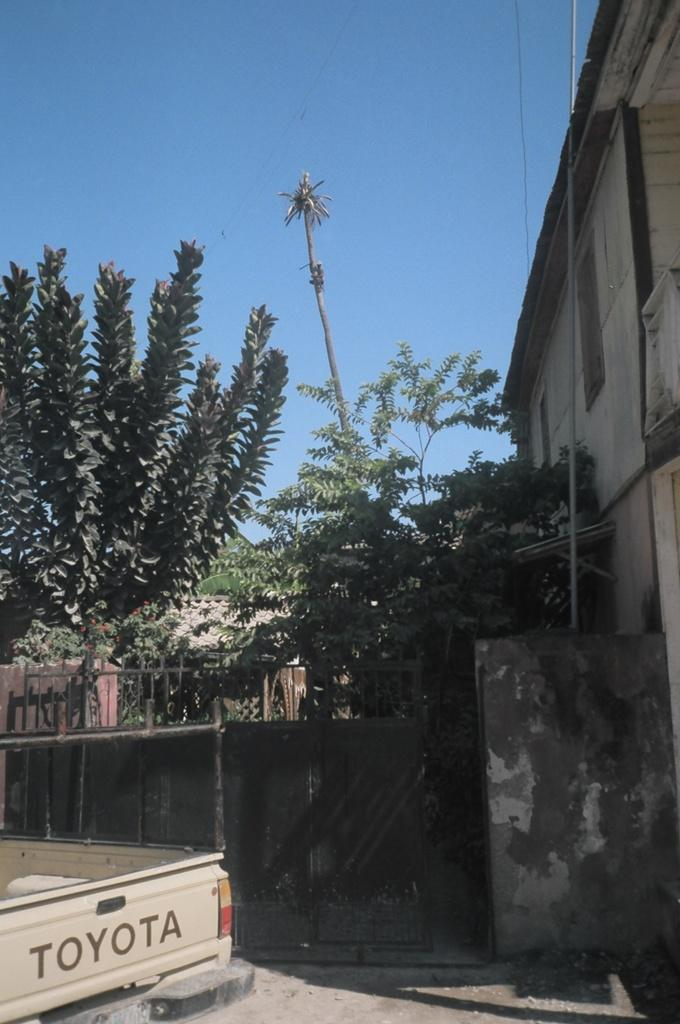What type of vehicle is in the image? There is a vehicle in the image, but the specific type is not mentioned. What color is the vehicle? The vehicle is cream in color. Where is the vehicle located in the image? The vehicle is on the ground. What structures are present in the image? There is a gate, a wall, and a building in the image. What type of vegetation is in the image? There are trees in the image. What can be seen in the background of the image? The sky is visible in the background of the image. What type of watch is the vehicle wearing in the image? There is no watch present in the image, as vehicles do not wear watches. 